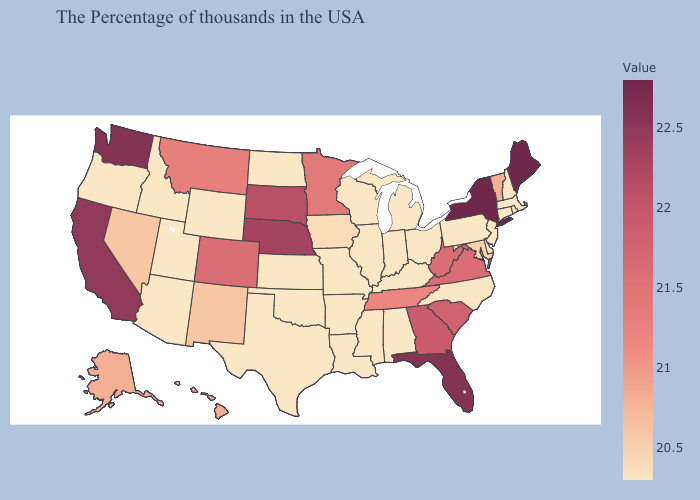Does Hawaii have the lowest value in the West?
Be succinct. No. Does Maine have the highest value in the Northeast?
Short answer required. Yes. Does Iowa have the lowest value in the USA?
Short answer required. No. Does Alaska have the highest value in the West?
Answer briefly. No. Does Delaware have a higher value than Tennessee?
Answer briefly. No. 